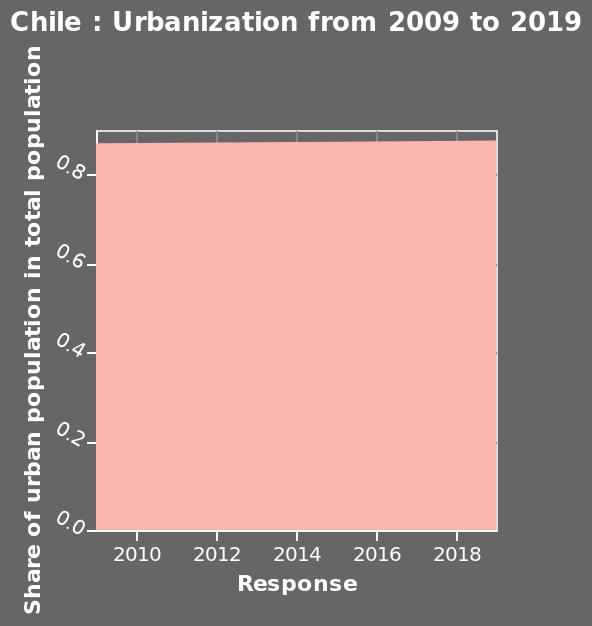<image>
What does the y-axis measure in the area diagram? The y-axis in the area diagram measures the share of urban population in the total population. How has the response to the share of the urban population in total population been over the past decade?  The response has stayed consistent from 2009 to 2019 regarding the share of the urban population in total population. Has the response to the share of the urban population in total population changed from 2009 to 2019?  No, the response has remained the same from 2009 to 2019. Does the y-axis in the area diagram measure the share of rural population in the total population? No.The y-axis in the area diagram measures the share of urban population in the total population. 